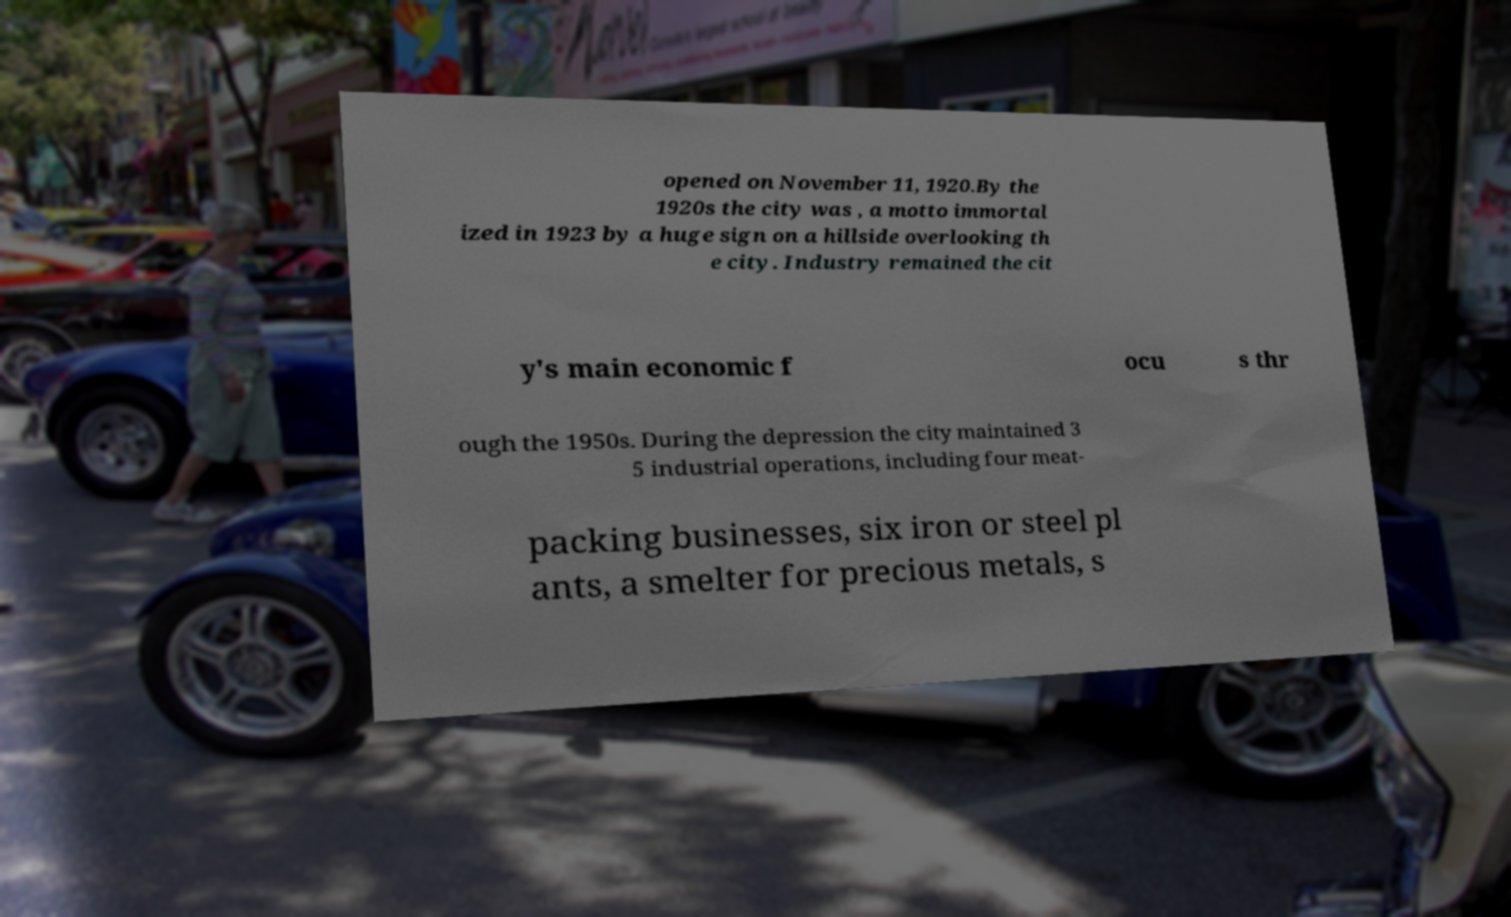For documentation purposes, I need the text within this image transcribed. Could you provide that? opened on November 11, 1920.By the 1920s the city was , a motto immortal ized in 1923 by a huge sign on a hillside overlooking th e city. Industry remained the cit y's main economic f ocu s thr ough the 1950s. During the depression the city maintained 3 5 industrial operations, including four meat- packing businesses, six iron or steel pl ants, a smelter for precious metals, s 